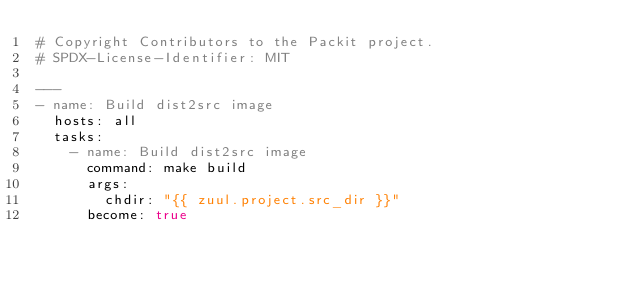<code> <loc_0><loc_0><loc_500><loc_500><_YAML_># Copyright Contributors to the Packit project.
# SPDX-License-Identifier: MIT

---
- name: Build dist2src image
  hosts: all
  tasks:
    - name: Build dist2src image
      command: make build
      args:
        chdir: "{{ zuul.project.src_dir }}"
      become: true
</code> 